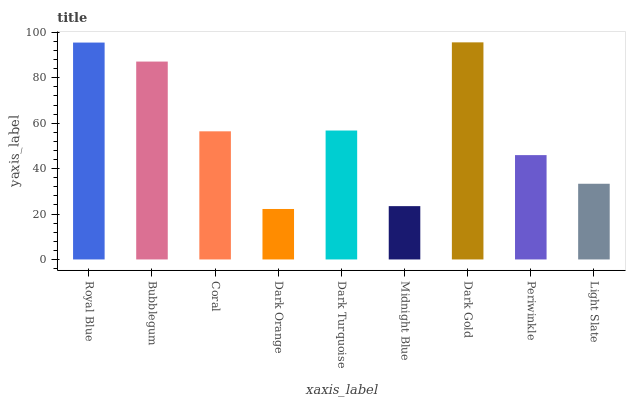Is Dark Orange the minimum?
Answer yes or no. Yes. Is Dark Gold the maximum?
Answer yes or no. Yes. Is Bubblegum the minimum?
Answer yes or no. No. Is Bubblegum the maximum?
Answer yes or no. No. Is Royal Blue greater than Bubblegum?
Answer yes or no. Yes. Is Bubblegum less than Royal Blue?
Answer yes or no. Yes. Is Bubblegum greater than Royal Blue?
Answer yes or no. No. Is Royal Blue less than Bubblegum?
Answer yes or no. No. Is Coral the high median?
Answer yes or no. Yes. Is Coral the low median?
Answer yes or no. Yes. Is Royal Blue the high median?
Answer yes or no. No. Is Bubblegum the low median?
Answer yes or no. No. 